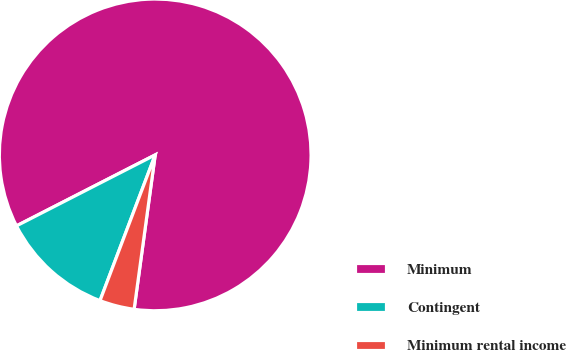<chart> <loc_0><loc_0><loc_500><loc_500><pie_chart><fcel>Minimum<fcel>Contingent<fcel>Minimum rental income<nl><fcel>84.68%<fcel>11.71%<fcel>3.6%<nl></chart> 